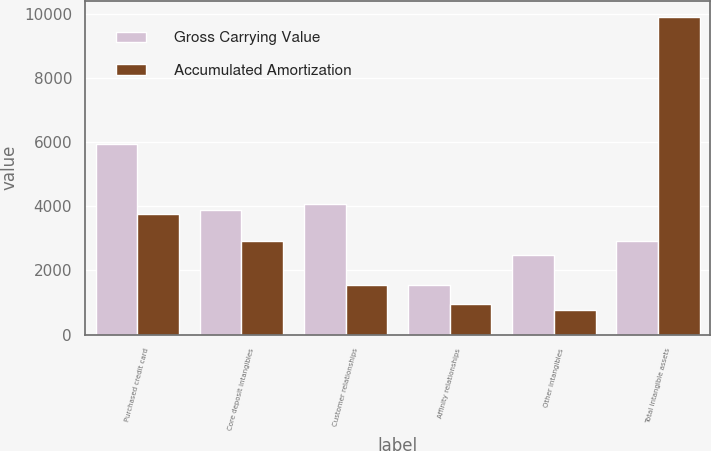<chart> <loc_0><loc_0><loc_500><loc_500><stacked_bar_chart><ecel><fcel>Purchased credit card<fcel>Core deposit intangibles<fcel>Customer relationships<fcel>Affinity relationships<fcel>Other intangibles<fcel>Total intangible assets<nl><fcel>Gross Carrying Value<fcel>5938<fcel>3903<fcel>4081<fcel>1551<fcel>2476<fcel>2915<nl><fcel>Accumulated Amortization<fcel>3765<fcel>2915<fcel>1532<fcel>948<fcel>768<fcel>9928<nl></chart> 